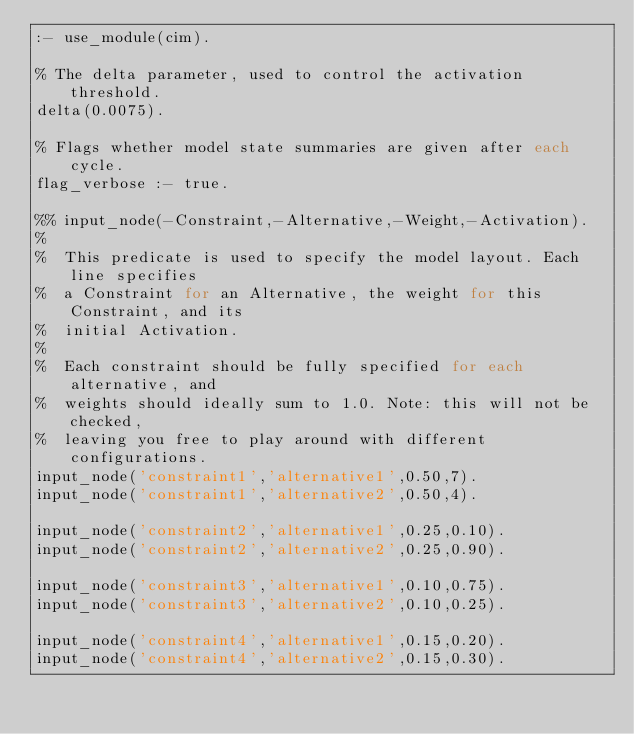Convert code to text. <code><loc_0><loc_0><loc_500><loc_500><_Perl_>:- use_module(cim).

% The delta parameter, used to control the activation threshold.
delta(0.0075).

% Flags whether model state summaries are given after each cycle.
flag_verbose :- true.

%% input_node(-Constraint,-Alternative,-Weight,-Activation).
%
%  This predicate is used to specify the model layout. Each line specifies
%  a Constraint for an Alternative, the weight for this Constraint, and its
%  initial Activation.
%
%  Each constraint should be fully specified for each alternative, and
%  weights should ideally sum to 1.0. Note: this will not be checked,
%  leaving you free to play around with different configurations.
input_node('constraint1','alternative1',0.50,7).
input_node('constraint1','alternative2',0.50,4).

input_node('constraint2','alternative1',0.25,0.10).
input_node('constraint2','alternative2',0.25,0.90).

input_node('constraint3','alternative1',0.10,0.75).
input_node('constraint3','alternative2',0.10,0.25).

input_node('constraint4','alternative1',0.15,0.20).
input_node('constraint4','alternative2',0.15,0.30).
</code> 